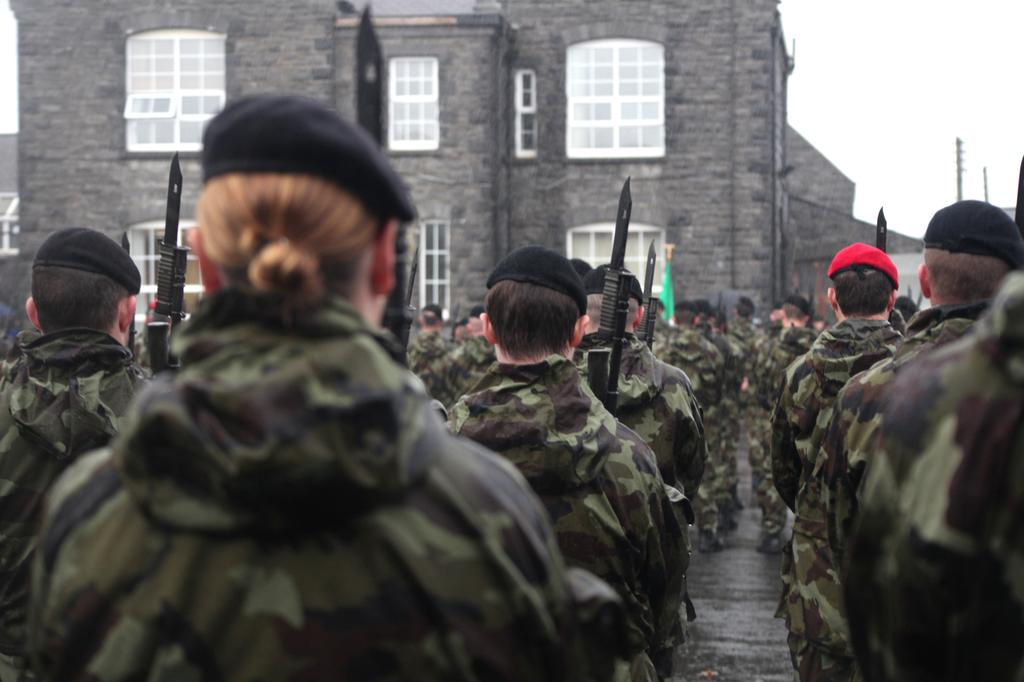How many people are in the image? There is a group of people in the image. What are the people doing in the image? The people are standing and holding weapons in their hands. What can be seen in the background of the image? There is a building and a glass window in the background of the image. What is visible at the top of the image? The sky is visible at the top of the image. What type of rings can be seen on the people's fingers in the image? There are no rings visible on the people's fingers in the image. How does the drum contribute to the scene in the image? There is no drum present in the image. 